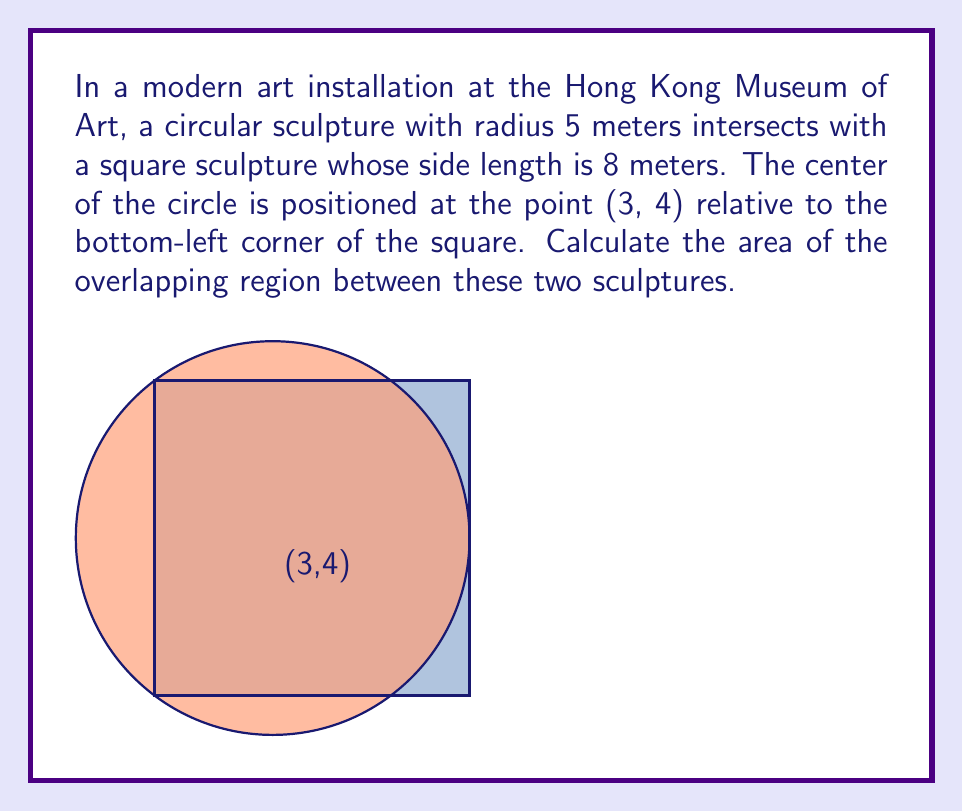Solve this math problem. To solve this problem, we'll follow these steps:

1) First, we need to find the points of intersection between the circle and the square. The circle's equation is:

   $$(x-3)^2 + (y-4)^2 = 5^2 = 25$$

2) We'll check each side of the square:
   
   Left side: $x = 0$, $0 \leq y \leq 8$
   Right side: $x = 8$, $0 \leq y \leq 8$
   Bottom side: $y = 0$, $0 \leq x \leq 8$
   Top side: $y = 8$, $0 \leq x \leq 8$

3) Substituting these into the circle equation:

   Left: $(0-3)^2 + (y-4)^2 = 25$ → $y = 4 \pm \sqrt{16} = 4 \pm 4$
   Right: $(8-3)^2 + (y-4)^2 = 25$ → $y = 4 \pm \sqrt{0} = 4$
   Bottom: $(x-3)^2 + (0-4)^2 = 25$ → $x = 3 \pm \sqrt{9} = 3 \pm 3$
   Top: $(x-3)^2 + (8-4)^2 = 25$ → $x = 3 \pm \sqrt{9} = 3 \pm 3$

4) The valid intersection points are:
   $(0, 8)$, $(0, 0)$, $(6, 8)$, $(6, 0)$

5) The overlapping region consists of a circular segment and a rectangle. We'll calculate these areas separately:

   Rectangle area: $6 * 8 = 48$ sq meters

   Circular segment area: 
   $A_{segment} = r^2 \arccos(\frac{r-h}{r}) - (r-h)\sqrt{2rh-h^2}$
   where $r = 5$ and $h = 5 - 3 = 2$

   $A_{segment} = 25 \arccos(\frac{3}{5}) - 3\sqrt{20-4}$
                $= 25 * 0.9273 - 3 * 4$
                $\approx 11.1825$

6) Total overlapping area:
   $48 + 2 * 11.1825 = 70.365$ sq meters
Answer: $$70.365 \text{ sq meters}$$ 